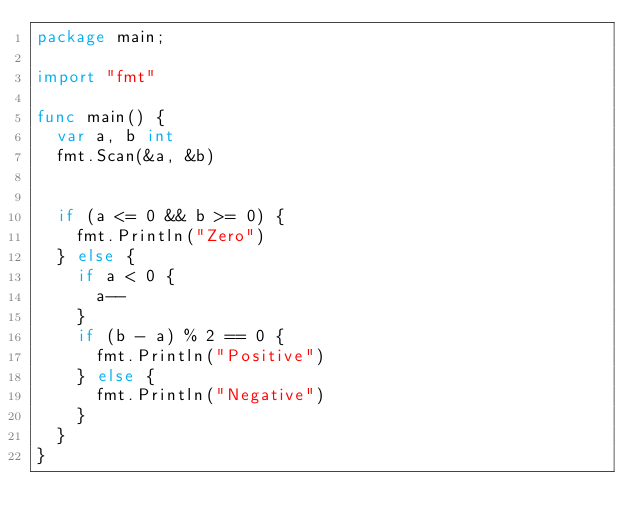Convert code to text. <code><loc_0><loc_0><loc_500><loc_500><_Go_>package main;

import "fmt"

func main() {
	var a, b int
	fmt.Scan(&a, &b)


	if (a <= 0 && b >= 0) {
		fmt.Println("Zero")
	} else {
		if a < 0 {
			a--
		}
		if (b - a) % 2 == 0 {
			fmt.Println("Positive")
		} else {
			fmt.Println("Negative")
		}
	}
}</code> 